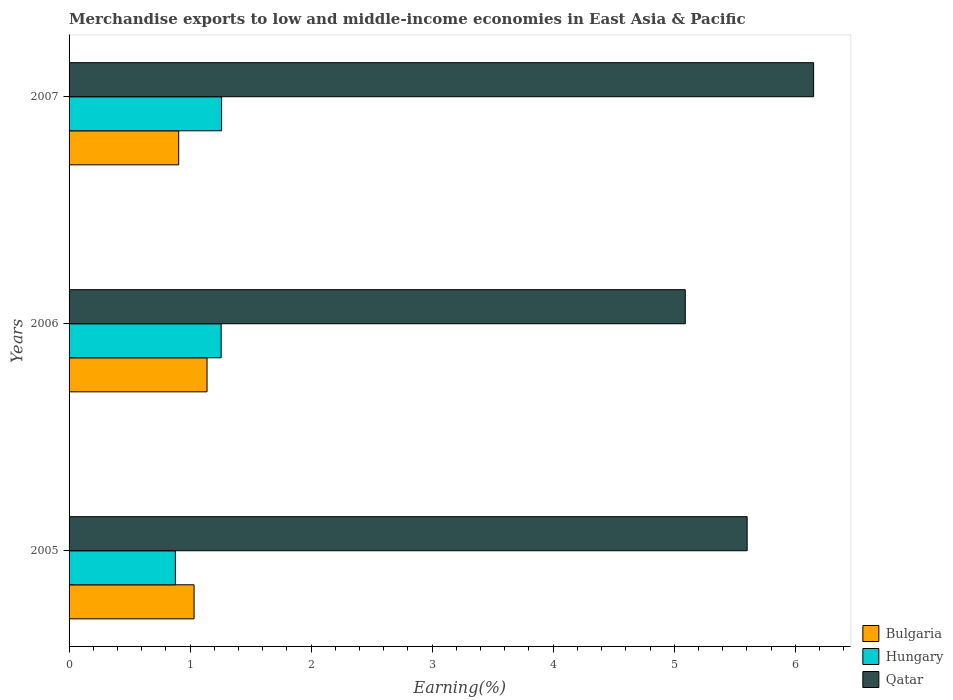Are the number of bars per tick equal to the number of legend labels?
Provide a succinct answer. Yes. How many bars are there on the 1st tick from the bottom?
Offer a terse response. 3. What is the label of the 2nd group of bars from the top?
Your answer should be very brief. 2006. In how many cases, is the number of bars for a given year not equal to the number of legend labels?
Provide a short and direct response. 0. What is the percentage of amount earned from merchandise exports in Hungary in 2005?
Provide a short and direct response. 0.88. Across all years, what is the maximum percentage of amount earned from merchandise exports in Qatar?
Offer a very short reply. 6.15. Across all years, what is the minimum percentage of amount earned from merchandise exports in Qatar?
Ensure brevity in your answer.  5.09. In which year was the percentage of amount earned from merchandise exports in Hungary maximum?
Make the answer very short. 2007. What is the total percentage of amount earned from merchandise exports in Hungary in the graph?
Offer a very short reply. 3.4. What is the difference between the percentage of amount earned from merchandise exports in Hungary in 2005 and that in 2006?
Ensure brevity in your answer.  -0.38. What is the difference between the percentage of amount earned from merchandise exports in Hungary in 2005 and the percentage of amount earned from merchandise exports in Bulgaria in 2007?
Your response must be concise. -0.03. What is the average percentage of amount earned from merchandise exports in Hungary per year?
Your answer should be compact. 1.13. In the year 2007, what is the difference between the percentage of amount earned from merchandise exports in Bulgaria and percentage of amount earned from merchandise exports in Qatar?
Keep it short and to the point. -5.25. In how many years, is the percentage of amount earned from merchandise exports in Qatar greater than 6.2 %?
Your answer should be compact. 0. What is the ratio of the percentage of amount earned from merchandise exports in Bulgaria in 2005 to that in 2006?
Ensure brevity in your answer.  0.91. Is the percentage of amount earned from merchandise exports in Hungary in 2005 less than that in 2007?
Keep it short and to the point. Yes. What is the difference between the highest and the second highest percentage of amount earned from merchandise exports in Qatar?
Offer a very short reply. 0.55. What is the difference between the highest and the lowest percentage of amount earned from merchandise exports in Hungary?
Your response must be concise. 0.38. In how many years, is the percentage of amount earned from merchandise exports in Bulgaria greater than the average percentage of amount earned from merchandise exports in Bulgaria taken over all years?
Keep it short and to the point. 2. What does the 1st bar from the top in 2005 represents?
Provide a short and direct response. Qatar. What does the 3rd bar from the bottom in 2007 represents?
Ensure brevity in your answer.  Qatar. How many bars are there?
Give a very brief answer. 9. Are all the bars in the graph horizontal?
Ensure brevity in your answer.  Yes. How many years are there in the graph?
Your answer should be very brief. 3. What is the difference between two consecutive major ticks on the X-axis?
Make the answer very short. 1. Are the values on the major ticks of X-axis written in scientific E-notation?
Your answer should be very brief. No. Where does the legend appear in the graph?
Provide a short and direct response. Bottom right. What is the title of the graph?
Offer a terse response. Merchandise exports to low and middle-income economies in East Asia & Pacific. What is the label or title of the X-axis?
Ensure brevity in your answer.  Earning(%). What is the label or title of the Y-axis?
Your response must be concise. Years. What is the Earning(%) in Bulgaria in 2005?
Your response must be concise. 1.03. What is the Earning(%) in Hungary in 2005?
Keep it short and to the point. 0.88. What is the Earning(%) of Qatar in 2005?
Keep it short and to the point. 5.6. What is the Earning(%) of Bulgaria in 2006?
Give a very brief answer. 1.14. What is the Earning(%) of Hungary in 2006?
Provide a short and direct response. 1.26. What is the Earning(%) in Qatar in 2006?
Your answer should be very brief. 5.09. What is the Earning(%) of Bulgaria in 2007?
Keep it short and to the point. 0.91. What is the Earning(%) of Hungary in 2007?
Provide a short and direct response. 1.26. What is the Earning(%) of Qatar in 2007?
Give a very brief answer. 6.15. Across all years, what is the maximum Earning(%) in Bulgaria?
Offer a very short reply. 1.14. Across all years, what is the maximum Earning(%) of Hungary?
Offer a terse response. 1.26. Across all years, what is the maximum Earning(%) of Qatar?
Your answer should be very brief. 6.15. Across all years, what is the minimum Earning(%) in Bulgaria?
Your answer should be compact. 0.91. Across all years, what is the minimum Earning(%) in Hungary?
Offer a terse response. 0.88. Across all years, what is the minimum Earning(%) of Qatar?
Keep it short and to the point. 5.09. What is the total Earning(%) of Bulgaria in the graph?
Provide a short and direct response. 3.08. What is the total Earning(%) of Hungary in the graph?
Your answer should be compact. 3.4. What is the total Earning(%) of Qatar in the graph?
Provide a short and direct response. 16.85. What is the difference between the Earning(%) of Bulgaria in 2005 and that in 2006?
Offer a very short reply. -0.11. What is the difference between the Earning(%) of Hungary in 2005 and that in 2006?
Provide a short and direct response. -0.38. What is the difference between the Earning(%) of Qatar in 2005 and that in 2006?
Your answer should be compact. 0.51. What is the difference between the Earning(%) of Bulgaria in 2005 and that in 2007?
Ensure brevity in your answer.  0.13. What is the difference between the Earning(%) of Hungary in 2005 and that in 2007?
Give a very brief answer. -0.38. What is the difference between the Earning(%) of Qatar in 2005 and that in 2007?
Offer a very short reply. -0.55. What is the difference between the Earning(%) in Bulgaria in 2006 and that in 2007?
Your response must be concise. 0.23. What is the difference between the Earning(%) of Hungary in 2006 and that in 2007?
Give a very brief answer. -0. What is the difference between the Earning(%) of Qatar in 2006 and that in 2007?
Offer a terse response. -1.06. What is the difference between the Earning(%) of Bulgaria in 2005 and the Earning(%) of Hungary in 2006?
Provide a succinct answer. -0.22. What is the difference between the Earning(%) of Bulgaria in 2005 and the Earning(%) of Qatar in 2006?
Provide a short and direct response. -4.06. What is the difference between the Earning(%) of Hungary in 2005 and the Earning(%) of Qatar in 2006?
Provide a succinct answer. -4.21. What is the difference between the Earning(%) of Bulgaria in 2005 and the Earning(%) of Hungary in 2007?
Your answer should be compact. -0.23. What is the difference between the Earning(%) of Bulgaria in 2005 and the Earning(%) of Qatar in 2007?
Make the answer very short. -5.12. What is the difference between the Earning(%) in Hungary in 2005 and the Earning(%) in Qatar in 2007?
Offer a very short reply. -5.27. What is the difference between the Earning(%) in Bulgaria in 2006 and the Earning(%) in Hungary in 2007?
Make the answer very short. -0.12. What is the difference between the Earning(%) in Bulgaria in 2006 and the Earning(%) in Qatar in 2007?
Give a very brief answer. -5.01. What is the difference between the Earning(%) of Hungary in 2006 and the Earning(%) of Qatar in 2007?
Offer a terse response. -4.89. What is the average Earning(%) of Bulgaria per year?
Ensure brevity in your answer.  1.03. What is the average Earning(%) of Hungary per year?
Your response must be concise. 1.13. What is the average Earning(%) in Qatar per year?
Your answer should be compact. 5.62. In the year 2005, what is the difference between the Earning(%) of Bulgaria and Earning(%) of Hungary?
Provide a succinct answer. 0.15. In the year 2005, what is the difference between the Earning(%) in Bulgaria and Earning(%) in Qatar?
Your answer should be compact. -4.57. In the year 2005, what is the difference between the Earning(%) of Hungary and Earning(%) of Qatar?
Offer a terse response. -4.72. In the year 2006, what is the difference between the Earning(%) of Bulgaria and Earning(%) of Hungary?
Offer a very short reply. -0.12. In the year 2006, what is the difference between the Earning(%) of Bulgaria and Earning(%) of Qatar?
Provide a short and direct response. -3.95. In the year 2006, what is the difference between the Earning(%) in Hungary and Earning(%) in Qatar?
Provide a short and direct response. -3.83. In the year 2007, what is the difference between the Earning(%) of Bulgaria and Earning(%) of Hungary?
Your answer should be very brief. -0.35. In the year 2007, what is the difference between the Earning(%) in Bulgaria and Earning(%) in Qatar?
Provide a succinct answer. -5.25. In the year 2007, what is the difference between the Earning(%) of Hungary and Earning(%) of Qatar?
Provide a short and direct response. -4.89. What is the ratio of the Earning(%) of Bulgaria in 2005 to that in 2006?
Your answer should be compact. 0.91. What is the ratio of the Earning(%) in Hungary in 2005 to that in 2006?
Your answer should be compact. 0.7. What is the ratio of the Earning(%) in Qatar in 2005 to that in 2006?
Offer a terse response. 1.1. What is the ratio of the Earning(%) of Bulgaria in 2005 to that in 2007?
Give a very brief answer. 1.14. What is the ratio of the Earning(%) in Hungary in 2005 to that in 2007?
Offer a very short reply. 0.7. What is the ratio of the Earning(%) of Qatar in 2005 to that in 2007?
Your answer should be very brief. 0.91. What is the ratio of the Earning(%) in Bulgaria in 2006 to that in 2007?
Make the answer very short. 1.26. What is the ratio of the Earning(%) in Qatar in 2006 to that in 2007?
Your answer should be very brief. 0.83. What is the difference between the highest and the second highest Earning(%) in Bulgaria?
Provide a short and direct response. 0.11. What is the difference between the highest and the second highest Earning(%) of Hungary?
Give a very brief answer. 0. What is the difference between the highest and the second highest Earning(%) in Qatar?
Give a very brief answer. 0.55. What is the difference between the highest and the lowest Earning(%) in Bulgaria?
Offer a very short reply. 0.23. What is the difference between the highest and the lowest Earning(%) in Hungary?
Your answer should be compact. 0.38. What is the difference between the highest and the lowest Earning(%) in Qatar?
Give a very brief answer. 1.06. 